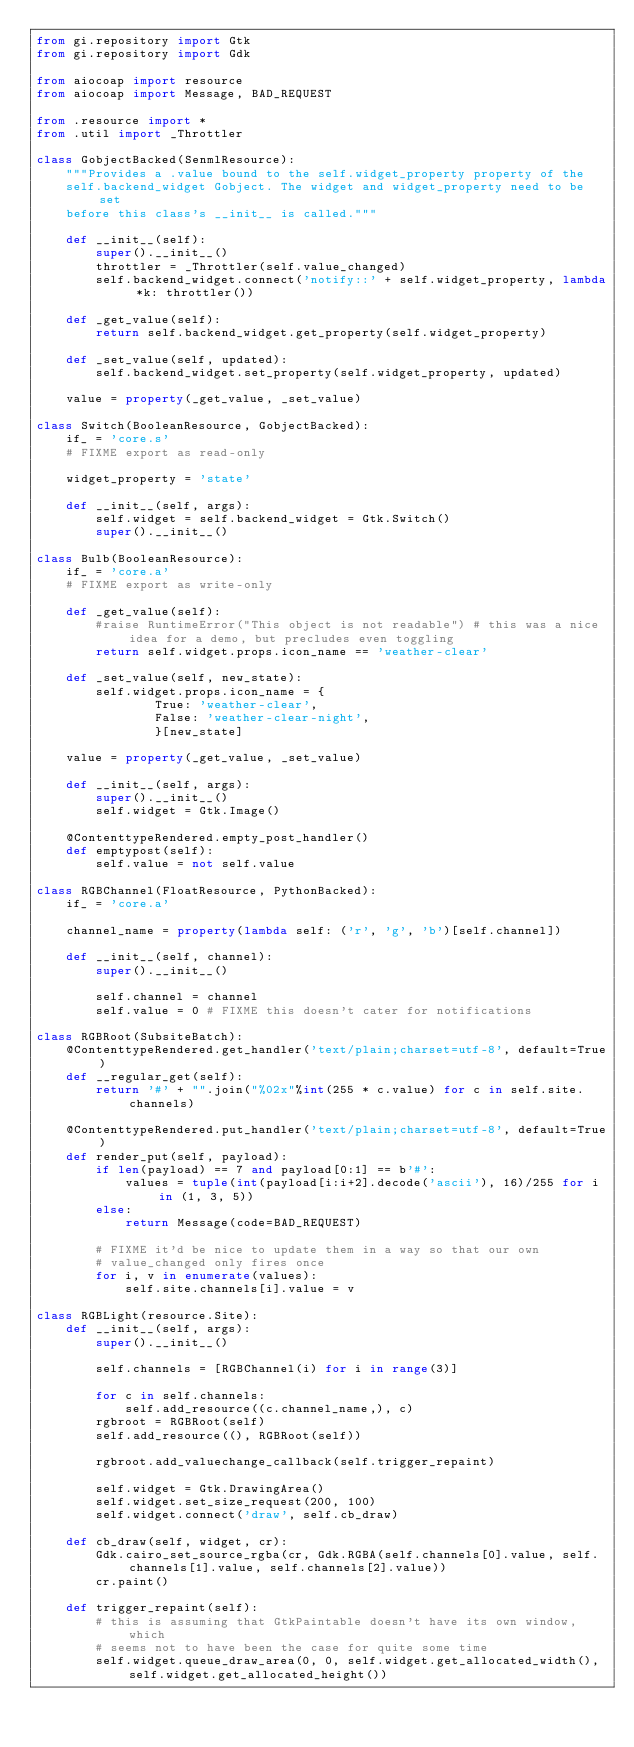<code> <loc_0><loc_0><loc_500><loc_500><_Python_>from gi.repository import Gtk
from gi.repository import Gdk

from aiocoap import resource
from aiocoap import Message, BAD_REQUEST

from .resource import *
from .util import _Throttler

class GobjectBacked(SenmlResource):
    """Provides a .value bound to the self.widget_property property of the
    self.backend_widget Gobject. The widget and widget_property need to be set
    before this class's __init__ is called."""

    def __init__(self):
        super().__init__()
        throttler = _Throttler(self.value_changed)
        self.backend_widget.connect('notify::' + self.widget_property, lambda *k: throttler())

    def _get_value(self):
        return self.backend_widget.get_property(self.widget_property)

    def _set_value(self, updated):
        self.backend_widget.set_property(self.widget_property, updated)

    value = property(_get_value, _set_value)

class Switch(BooleanResource, GobjectBacked):
    if_ = 'core.s'
    # FIXME export as read-only

    widget_property = 'state'

    def __init__(self, args):
        self.widget = self.backend_widget = Gtk.Switch()
        super().__init__()

class Bulb(BooleanResource):
    if_ = 'core.a'
    # FIXME export as write-only

    def _get_value(self):
        #raise RuntimeError("This object is not readable") # this was a nice idea for a demo, but precludes even toggling
        return self.widget.props.icon_name == 'weather-clear'

    def _set_value(self, new_state):
        self.widget.props.icon_name = {
                True: 'weather-clear',
                False: 'weather-clear-night',
                }[new_state]

    value = property(_get_value, _set_value)

    def __init__(self, args):
        super().__init__()
        self.widget = Gtk.Image()

    @ContenttypeRendered.empty_post_handler()
    def emptypost(self):
        self.value = not self.value

class RGBChannel(FloatResource, PythonBacked):
    if_ = 'core.a'

    channel_name = property(lambda self: ('r', 'g', 'b')[self.channel])

    def __init__(self, channel):
        super().__init__()

        self.channel = channel
        self.value = 0 # FIXME this doesn't cater for notifications

class RGBRoot(SubsiteBatch):
    @ContenttypeRendered.get_handler('text/plain;charset=utf-8', default=True)
    def __regular_get(self):
        return '#' + "".join("%02x"%int(255 * c.value) for c in self.site.channels)

    @ContenttypeRendered.put_handler('text/plain;charset=utf-8', default=True)
    def render_put(self, payload):
        if len(payload) == 7 and payload[0:1] == b'#':
            values = tuple(int(payload[i:i+2].decode('ascii'), 16)/255 for i in (1, 3, 5))
        else:
            return Message(code=BAD_REQUEST)

        # FIXME it'd be nice to update them in a way so that our own
        # value_changed only fires once
        for i, v in enumerate(values):
            self.site.channels[i].value = v

class RGBLight(resource.Site):
    def __init__(self, args):
        super().__init__()

        self.channels = [RGBChannel(i) for i in range(3)]

        for c in self.channels:
            self.add_resource((c.channel_name,), c)
        rgbroot = RGBRoot(self)
        self.add_resource((), RGBRoot(self))

        rgbroot.add_valuechange_callback(self.trigger_repaint)

        self.widget = Gtk.DrawingArea()
        self.widget.set_size_request(200, 100)
        self.widget.connect('draw', self.cb_draw)

    def cb_draw(self, widget, cr):
        Gdk.cairo_set_source_rgba(cr, Gdk.RGBA(self.channels[0].value, self.channels[1].value, self.channels[2].value))
        cr.paint()

    def trigger_repaint(self):
        # this is assuming that GtkPaintable doesn't have its own window, which
        # seems not to have been the case for quite some time
        self.widget.queue_draw_area(0, 0, self.widget.get_allocated_width(), self.widget.get_allocated_height())
</code> 